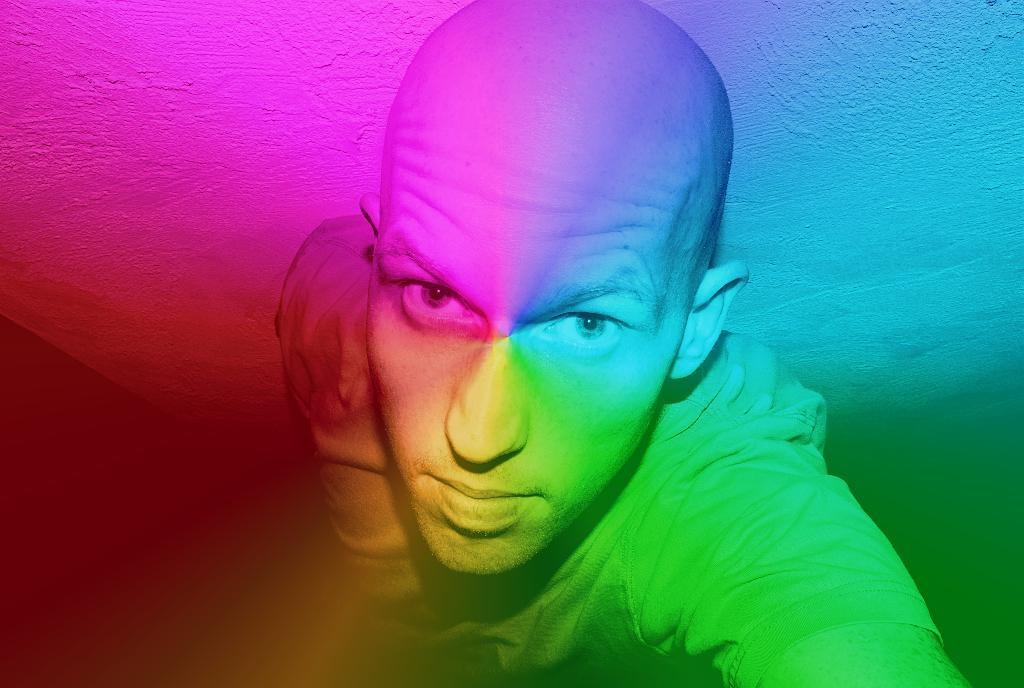What is the man in the image doing? The man is taking a selfie. Can you describe the man's appearance? The man has a bold head. What can be seen in the background of the image? There is a wall in the background of the image. What type of lighting is present in the image? There are lights in different colors in the image. What time does the clock in the image show? There is no clock present in the image. What type of grain is visible in the image? There is no grain visible in the image. 